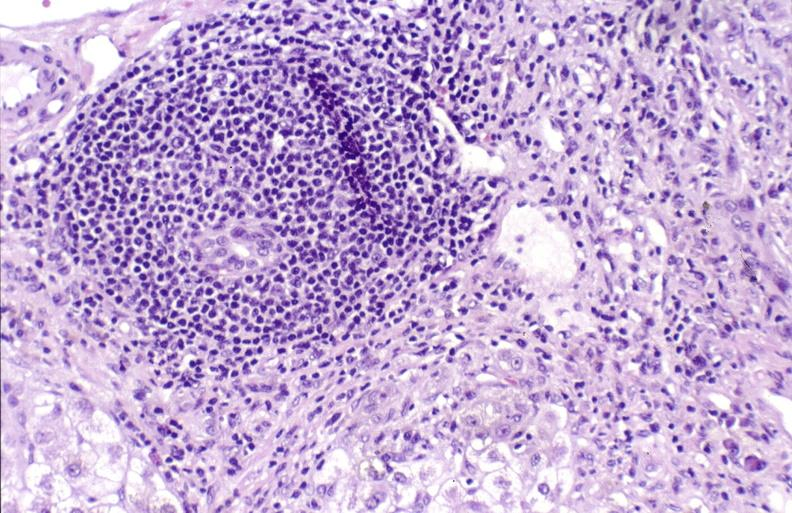s peritoneum present?
Answer the question using a single word or phrase. No 